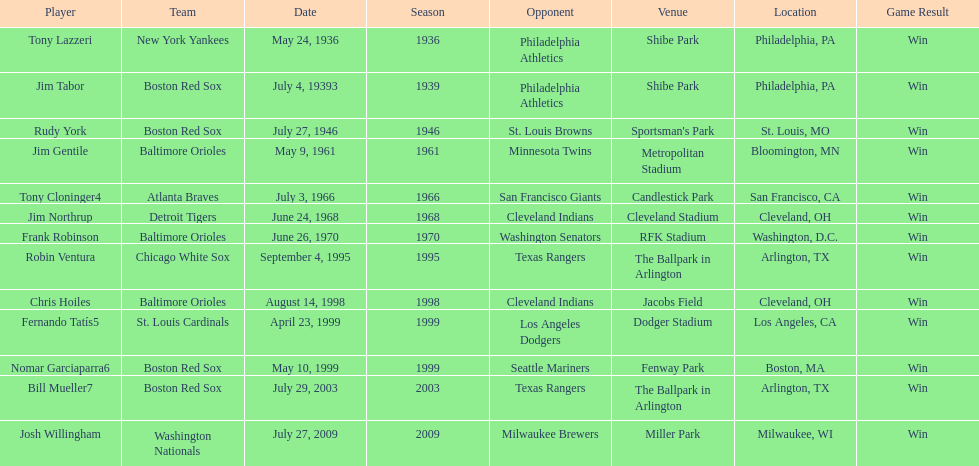What is the name of the player for the new york yankees in 1936? Tony Lazzeri. 